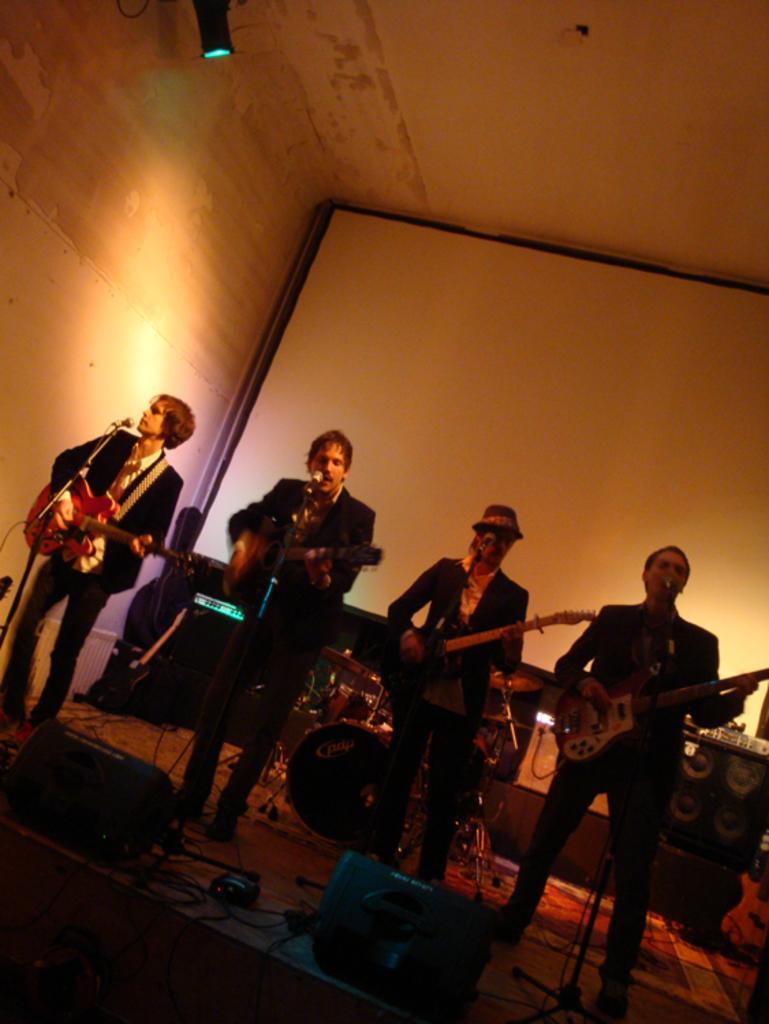Please provide a concise description of this image. In this picture we can see there are four people standing and holding the musical instruments. In front of the people there are microphones with stands, cables and some objects. Behind the people there are some musical instruments and it looks like a screen. On the left side of the people there is a wall and at the top there is a light. 